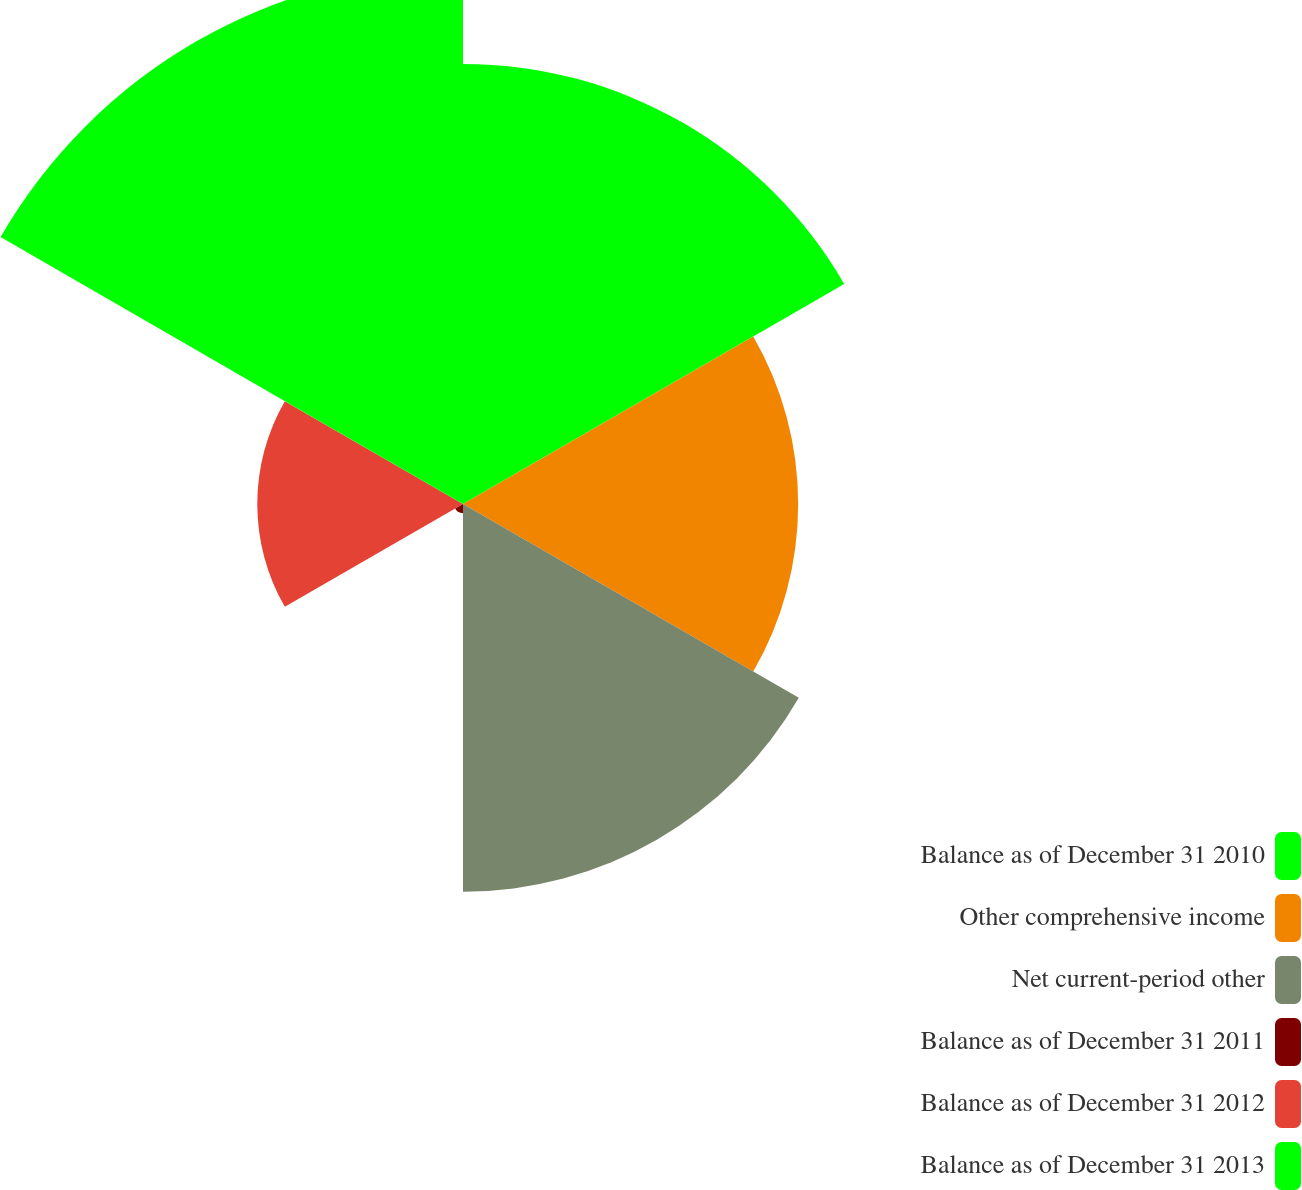Convert chart. <chart><loc_0><loc_0><loc_500><loc_500><pie_chart><fcel>Balance as of December 31 2010<fcel>Other comprehensive income<fcel>Net current-period other<fcel>Balance as of December 31 2011<fcel>Balance as of December 31 2012<fcel>Balance as of December 31 2013<nl><fcel>23.02%<fcel>17.53%<fcel>20.28%<fcel>0.48%<fcel>10.76%<fcel>27.93%<nl></chart> 